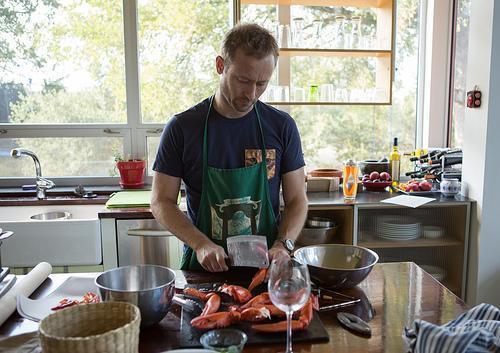How many wine glasses can be seen?
Give a very brief answer. 1. How many people are in the photo?
Give a very brief answer. 1. How many windows are in the photo?
Give a very brief answer. 1. 